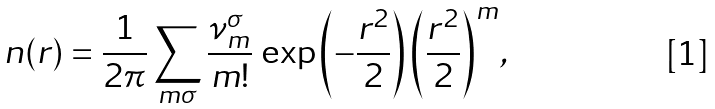Convert formula to latex. <formula><loc_0><loc_0><loc_500><loc_500>n ( r ) = \frac { 1 } { 2 \pi } \sum _ { m \sigma } \frac { \nu _ { m } ^ { \sigma } } { m ! } \, \exp { \left ( - \frac { r ^ { 2 } } { 2 } \right ) } \, { \left ( \frac { r ^ { 2 } } { 2 } \right ) } ^ { m } ,</formula> 